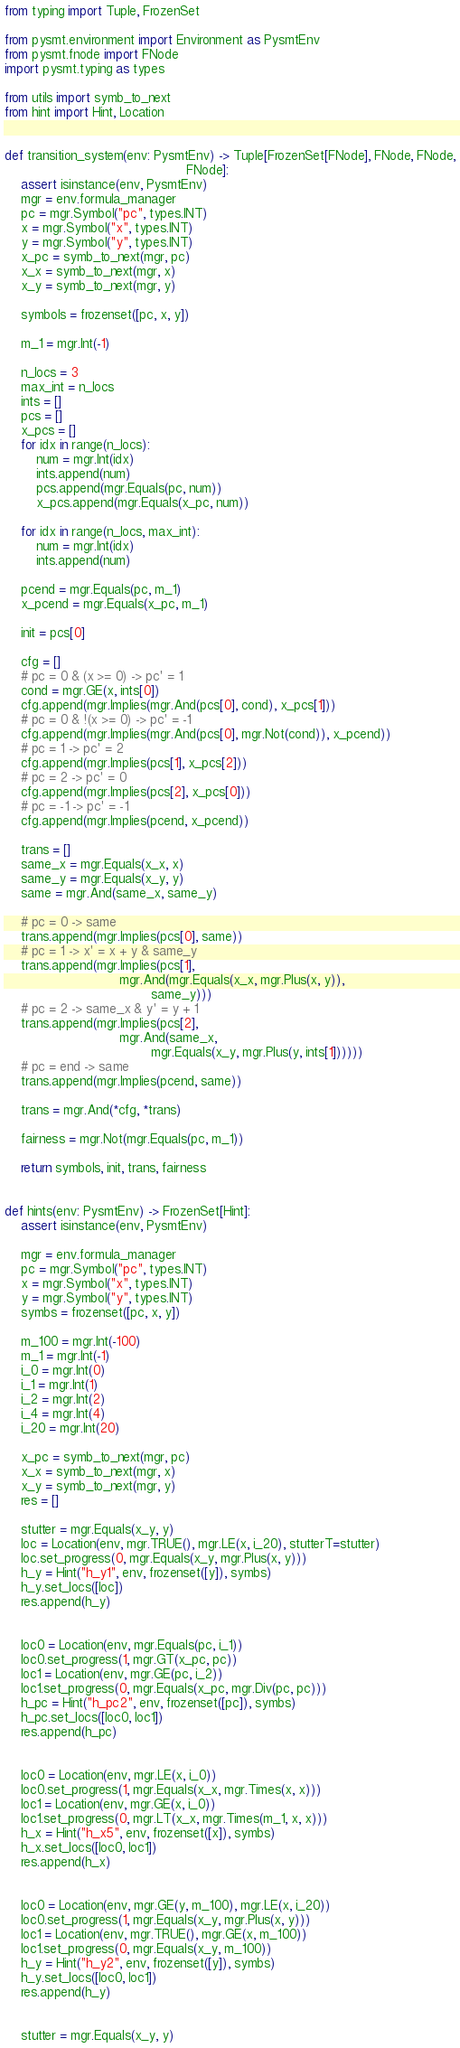<code> <loc_0><loc_0><loc_500><loc_500><_Python_>from typing import Tuple, FrozenSet

from pysmt.environment import Environment as PysmtEnv
from pysmt.fnode import FNode
import pysmt.typing as types

from utils import symb_to_next
from hint import Hint, Location


def transition_system(env: PysmtEnv) -> Tuple[FrozenSet[FNode], FNode, FNode,
                                              FNode]:
    assert isinstance(env, PysmtEnv)
    mgr = env.formula_manager
    pc = mgr.Symbol("pc", types.INT)
    x = mgr.Symbol("x", types.INT)
    y = mgr.Symbol("y", types.INT)
    x_pc = symb_to_next(mgr, pc)
    x_x = symb_to_next(mgr, x)
    x_y = symb_to_next(mgr, y)

    symbols = frozenset([pc, x, y])

    m_1 = mgr.Int(-1)

    n_locs = 3
    max_int = n_locs
    ints = []
    pcs = []
    x_pcs = []
    for idx in range(n_locs):
        num = mgr.Int(idx)
        ints.append(num)
        pcs.append(mgr.Equals(pc, num))
        x_pcs.append(mgr.Equals(x_pc, num))

    for idx in range(n_locs, max_int):
        num = mgr.Int(idx)
        ints.append(num)

    pcend = mgr.Equals(pc, m_1)
    x_pcend = mgr.Equals(x_pc, m_1)

    init = pcs[0]

    cfg = []
    # pc = 0 & (x >= 0) -> pc' = 1
    cond = mgr.GE(x, ints[0])
    cfg.append(mgr.Implies(mgr.And(pcs[0], cond), x_pcs[1]))
    # pc = 0 & !(x >= 0) -> pc' = -1
    cfg.append(mgr.Implies(mgr.And(pcs[0], mgr.Not(cond)), x_pcend))
    # pc = 1 -> pc' = 2
    cfg.append(mgr.Implies(pcs[1], x_pcs[2]))
    # pc = 2 -> pc' = 0
    cfg.append(mgr.Implies(pcs[2], x_pcs[0]))
    # pc = -1 -> pc' = -1
    cfg.append(mgr.Implies(pcend, x_pcend))

    trans = []
    same_x = mgr.Equals(x_x, x)
    same_y = mgr.Equals(x_y, y)
    same = mgr.And(same_x, same_y)

    # pc = 0 -> same
    trans.append(mgr.Implies(pcs[0], same))
    # pc = 1 -> x' = x + y & same_y
    trans.append(mgr.Implies(pcs[1],
                             mgr.And(mgr.Equals(x_x, mgr.Plus(x, y)),
                                     same_y)))
    # pc = 2 -> same_x & y' = y + 1
    trans.append(mgr.Implies(pcs[2],
                             mgr.And(same_x,
                                     mgr.Equals(x_y, mgr.Plus(y, ints[1])))))
    # pc = end -> same
    trans.append(mgr.Implies(pcend, same))

    trans = mgr.And(*cfg, *trans)

    fairness = mgr.Not(mgr.Equals(pc, m_1))

    return symbols, init, trans, fairness


def hints(env: PysmtEnv) -> FrozenSet[Hint]:
    assert isinstance(env, PysmtEnv)

    mgr = env.formula_manager
    pc = mgr.Symbol("pc", types.INT)
    x = mgr.Symbol("x", types.INT)
    y = mgr.Symbol("y", types.INT)
    symbs = frozenset([pc, x, y])

    m_100 = mgr.Int(-100)
    m_1 = mgr.Int(-1)
    i_0 = mgr.Int(0)
    i_1 = mgr.Int(1)
    i_2 = mgr.Int(2)
    i_4 = mgr.Int(4)
    i_20 = mgr.Int(20)

    x_pc = symb_to_next(mgr, pc)
    x_x = symb_to_next(mgr, x)
    x_y = symb_to_next(mgr, y)
    res = []

    stutter = mgr.Equals(x_y, y)
    loc = Location(env, mgr.TRUE(), mgr.LE(x, i_20), stutterT=stutter)
    loc.set_progress(0, mgr.Equals(x_y, mgr.Plus(x, y)))
    h_y = Hint("h_y1", env, frozenset([y]), symbs)
    h_y.set_locs([loc])
    res.append(h_y)


    loc0 = Location(env, mgr.Equals(pc, i_1))
    loc0.set_progress(1, mgr.GT(x_pc, pc))
    loc1 = Location(env, mgr.GE(pc, i_2))
    loc1.set_progress(0, mgr.Equals(x_pc, mgr.Div(pc, pc)))
    h_pc = Hint("h_pc2", env, frozenset([pc]), symbs)
    h_pc.set_locs([loc0, loc1])
    res.append(h_pc)


    loc0 = Location(env, mgr.LE(x, i_0))
    loc0.set_progress(1, mgr.Equals(x_x, mgr.Times(x, x)))
    loc1 = Location(env, mgr.GE(x, i_0))
    loc1.set_progress(0, mgr.LT(x_x, mgr.Times(m_1, x, x)))
    h_x = Hint("h_x5", env, frozenset([x]), symbs)
    h_x.set_locs([loc0, loc1])
    res.append(h_x)


    loc0 = Location(env, mgr.GE(y, m_100), mgr.LE(x, i_20))
    loc0.set_progress(1, mgr.Equals(x_y, mgr.Plus(x, y)))
    loc1 = Location(env, mgr.TRUE(), mgr.GE(x, m_100))
    loc1.set_progress(0, mgr.Equals(x_y, m_100))
    h_y = Hint("h_y2", env, frozenset([y]), symbs)
    h_y.set_locs([loc0, loc1])
    res.append(h_y)


    stutter = mgr.Equals(x_y, y)</code> 